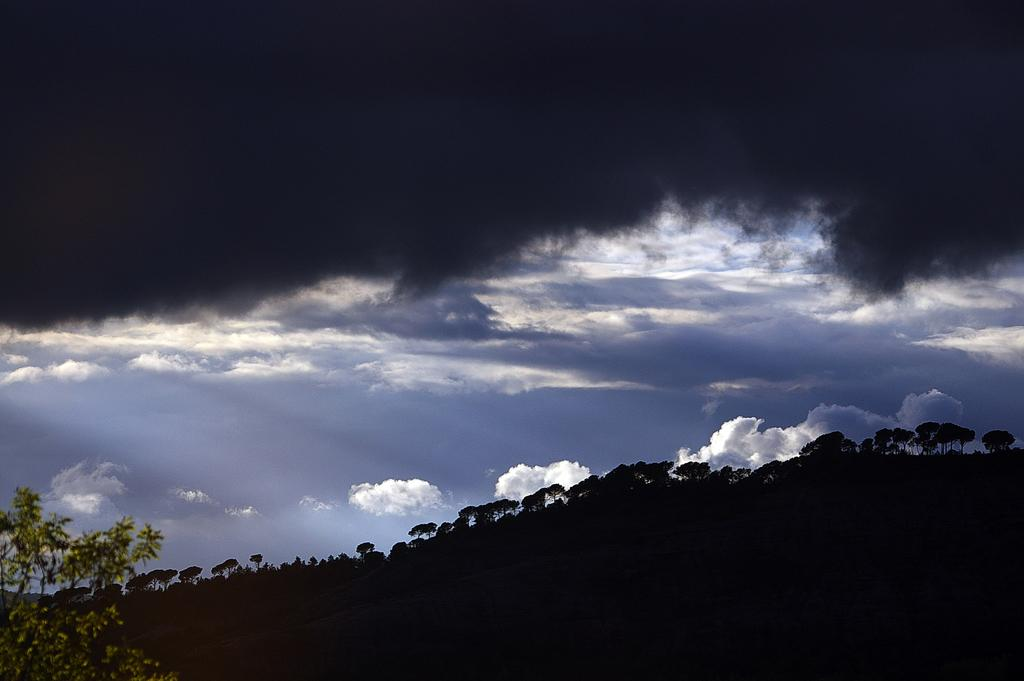What type of vegetation can be seen in the image? There are trees in the image. What is visible in the background of the image? The sky is visible in the background of the image. What can be observed in the sky? Clouds are present in the sky. What is the position of the society in the image? There is no society present in the image, so it is not possible to determine its position. 